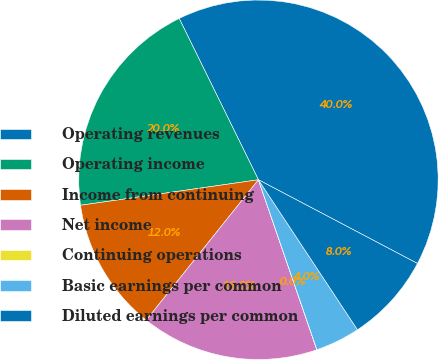<chart> <loc_0><loc_0><loc_500><loc_500><pie_chart><fcel>Operating revenues<fcel>Operating income<fcel>Income from continuing<fcel>Net income<fcel>Continuing operations<fcel>Basic earnings per common<fcel>Diluted earnings per common<nl><fcel>39.98%<fcel>20.0%<fcel>12.0%<fcel>16.0%<fcel>0.01%<fcel>4.01%<fcel>8.0%<nl></chart> 